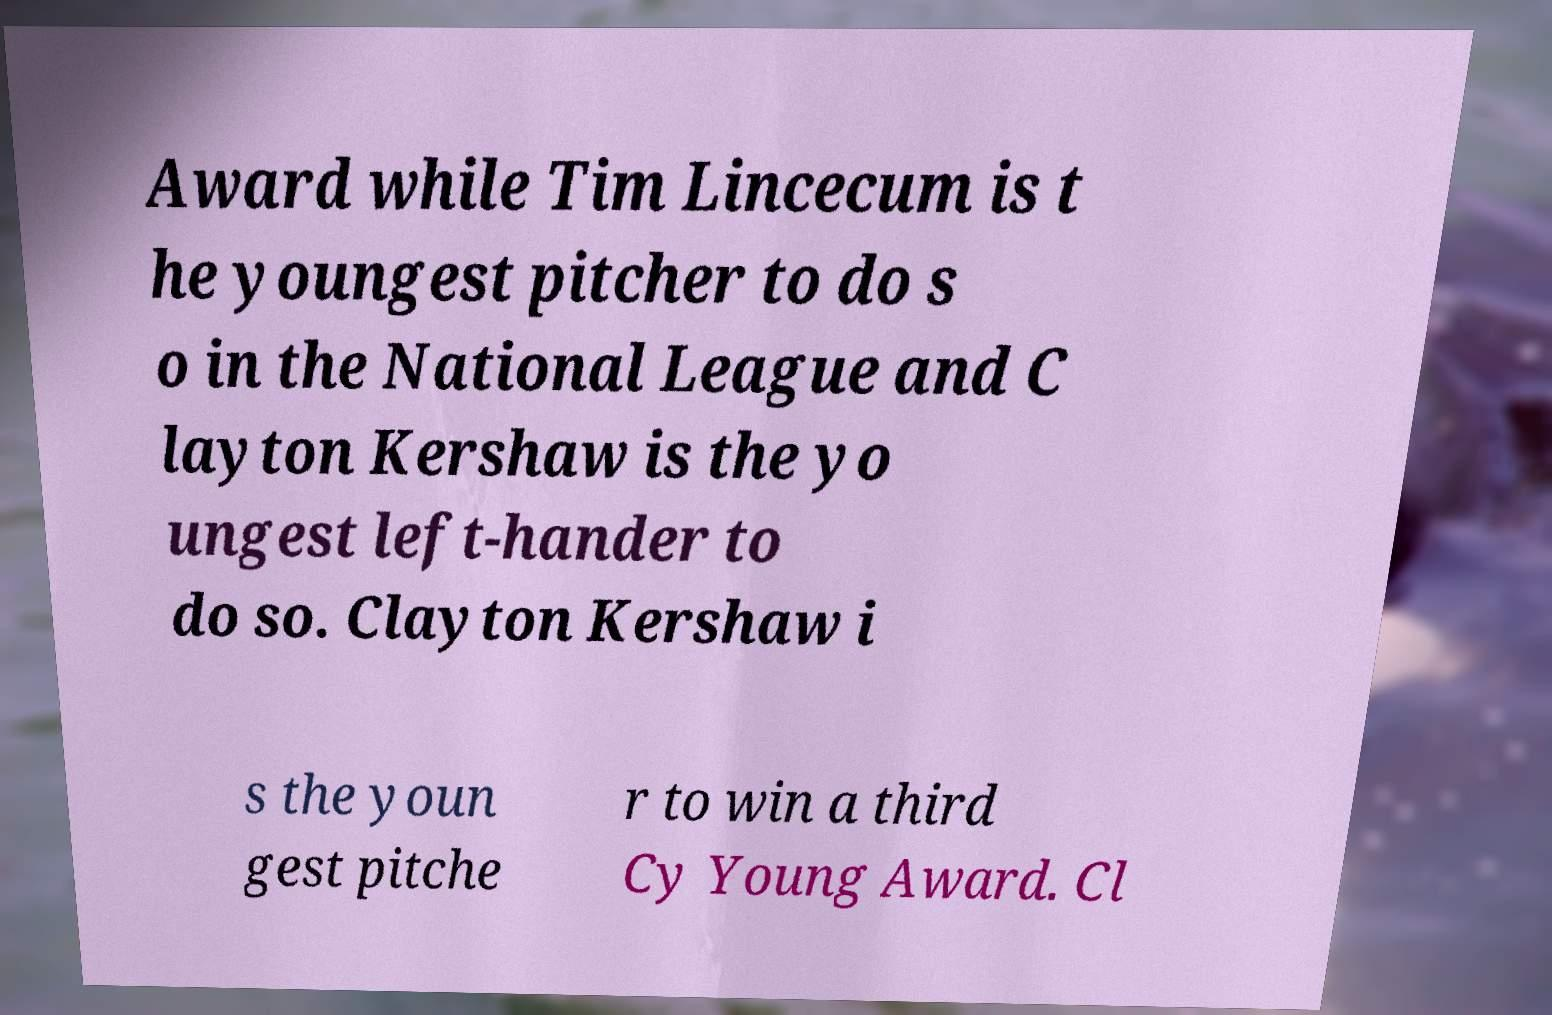Please identify and transcribe the text found in this image. Award while Tim Lincecum is t he youngest pitcher to do s o in the National League and C layton Kershaw is the yo ungest left-hander to do so. Clayton Kershaw i s the youn gest pitche r to win a third Cy Young Award. Cl 